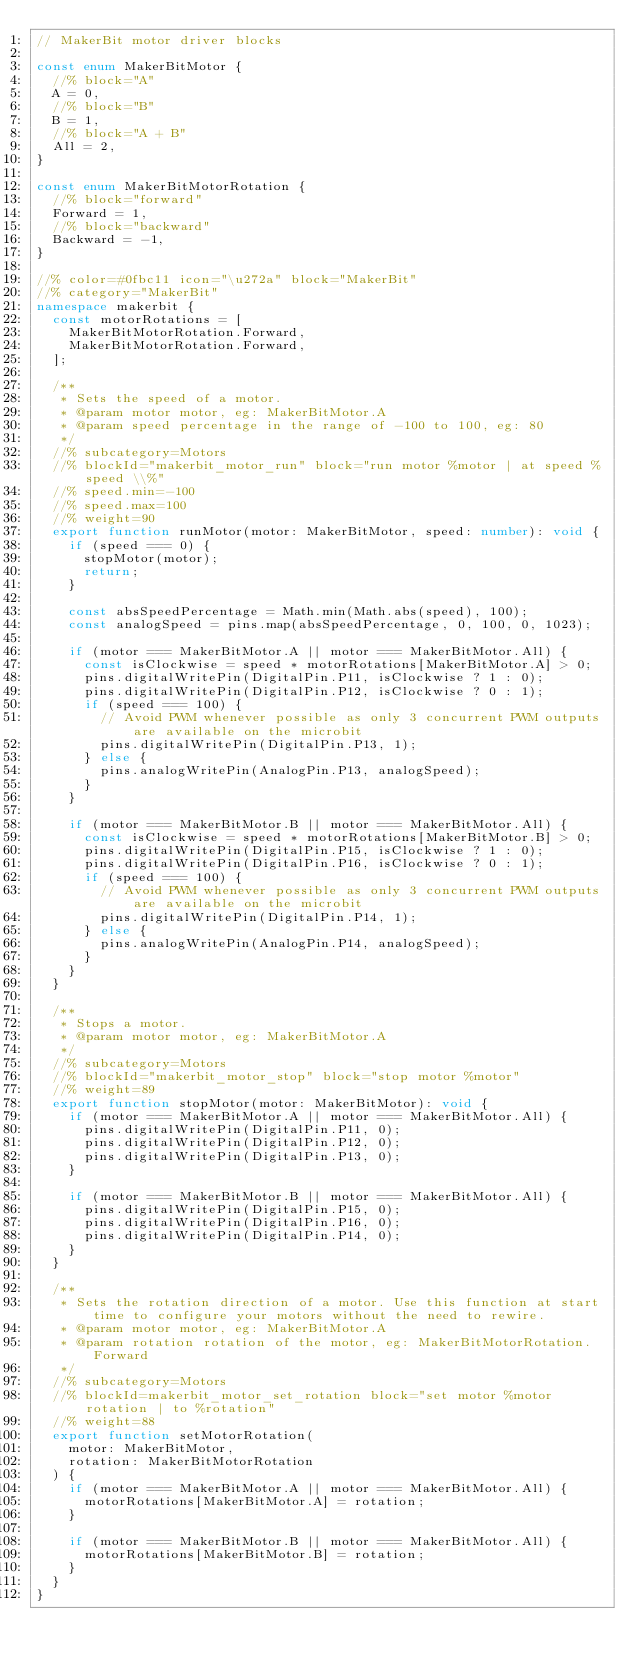<code> <loc_0><loc_0><loc_500><loc_500><_TypeScript_>// MakerBit motor driver blocks

const enum MakerBitMotor {
  //% block="A"
  A = 0,
  //% block="B"
  B = 1,
  //% block="A + B"
  All = 2,
}

const enum MakerBitMotorRotation {
  //% block="forward"
  Forward = 1,
  //% block="backward"
  Backward = -1,
}

//% color=#0fbc11 icon="\u272a" block="MakerBit"
//% category="MakerBit"
namespace makerbit {
  const motorRotations = [
    MakerBitMotorRotation.Forward,
    MakerBitMotorRotation.Forward,
  ];

  /**
   * Sets the speed of a motor.
   * @param motor motor, eg: MakerBitMotor.A
   * @param speed percentage in the range of -100 to 100, eg: 80
   */
  //% subcategory=Motors
  //% blockId="makerbit_motor_run" block="run motor %motor | at speed %speed \\%"
  //% speed.min=-100
  //% speed.max=100
  //% weight=90
  export function runMotor(motor: MakerBitMotor, speed: number): void {
    if (speed === 0) {
      stopMotor(motor);
      return;
    }

    const absSpeedPercentage = Math.min(Math.abs(speed), 100);
    const analogSpeed = pins.map(absSpeedPercentage, 0, 100, 0, 1023);

    if (motor === MakerBitMotor.A || motor === MakerBitMotor.All) {
      const isClockwise = speed * motorRotations[MakerBitMotor.A] > 0;
      pins.digitalWritePin(DigitalPin.P11, isClockwise ? 1 : 0);
      pins.digitalWritePin(DigitalPin.P12, isClockwise ? 0 : 1);
      if (speed === 100) {
        // Avoid PWM whenever possible as only 3 concurrent PWM outputs are available on the microbit
        pins.digitalWritePin(DigitalPin.P13, 1);
      } else {
        pins.analogWritePin(AnalogPin.P13, analogSpeed);
      }
    }

    if (motor === MakerBitMotor.B || motor === MakerBitMotor.All) {
      const isClockwise = speed * motorRotations[MakerBitMotor.B] > 0;
      pins.digitalWritePin(DigitalPin.P15, isClockwise ? 1 : 0);
      pins.digitalWritePin(DigitalPin.P16, isClockwise ? 0 : 1);
      if (speed === 100) {
        // Avoid PWM whenever possible as only 3 concurrent PWM outputs are available on the microbit
        pins.digitalWritePin(DigitalPin.P14, 1);
      } else {
        pins.analogWritePin(AnalogPin.P14, analogSpeed);
      }
    }
  }

  /**
   * Stops a motor.
   * @param motor motor, eg: MakerBitMotor.A
   */
  //% subcategory=Motors
  //% blockId="makerbit_motor_stop" block="stop motor %motor"
  //% weight=89
  export function stopMotor(motor: MakerBitMotor): void {
    if (motor === MakerBitMotor.A || motor === MakerBitMotor.All) {
      pins.digitalWritePin(DigitalPin.P11, 0);
      pins.digitalWritePin(DigitalPin.P12, 0);
      pins.digitalWritePin(DigitalPin.P13, 0);
    }

    if (motor === MakerBitMotor.B || motor === MakerBitMotor.All) {
      pins.digitalWritePin(DigitalPin.P15, 0);
      pins.digitalWritePin(DigitalPin.P16, 0);
      pins.digitalWritePin(DigitalPin.P14, 0);
    }
  }

  /**
   * Sets the rotation direction of a motor. Use this function at start time to configure your motors without the need to rewire.
   * @param motor motor, eg: MakerBitMotor.A
   * @param rotation rotation of the motor, eg: MakerBitMotorRotation.Forward
   */
  //% subcategory=Motors
  //% blockId=makerbit_motor_set_rotation block="set motor %motor rotation | to %rotation"
  //% weight=88
  export function setMotorRotation(
    motor: MakerBitMotor,
    rotation: MakerBitMotorRotation
  ) {
    if (motor === MakerBitMotor.A || motor === MakerBitMotor.All) {
      motorRotations[MakerBitMotor.A] = rotation;
    }

    if (motor === MakerBitMotor.B || motor === MakerBitMotor.All) {
      motorRotations[MakerBitMotor.B] = rotation;
    }
  }
}
</code> 